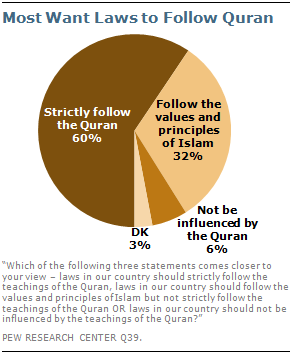List a handful of essential elements in this visual. Sixty percent represents a significant portion in the pie chart, and it should be interpreted and followed in accordance with the teachings of the Quran. The largest pie is of the color dark brown. 